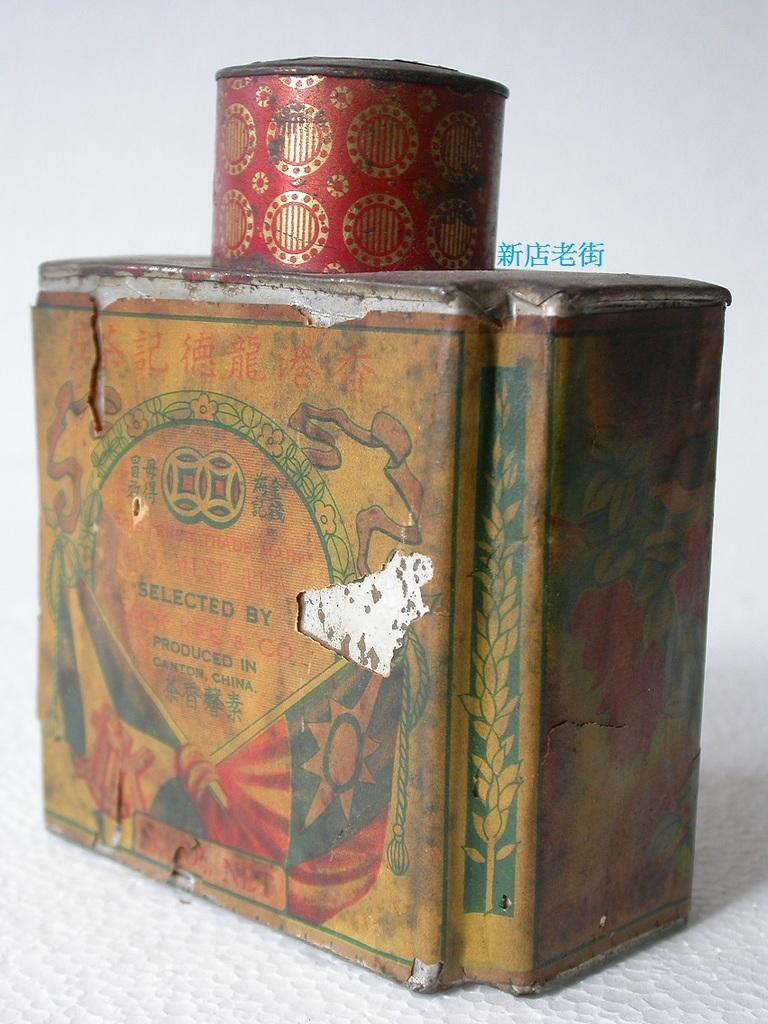<image>
Offer a succinct explanation of the picture presented. A dingy can of something that was produced in Canton China. 